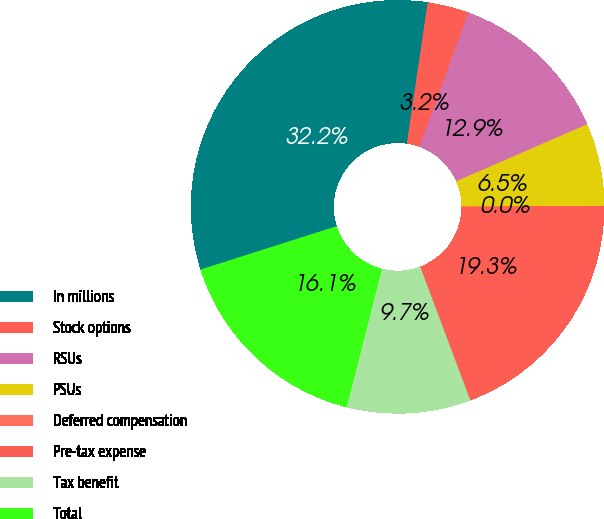<chart> <loc_0><loc_0><loc_500><loc_500><pie_chart><fcel>In millions<fcel>Stock options<fcel>RSUs<fcel>PSUs<fcel>Deferred compensation<fcel>Pre-tax expense<fcel>Tax benefit<fcel>Total<nl><fcel>32.24%<fcel>3.24%<fcel>12.9%<fcel>6.46%<fcel>0.01%<fcel>19.35%<fcel>9.68%<fcel>16.13%<nl></chart> 